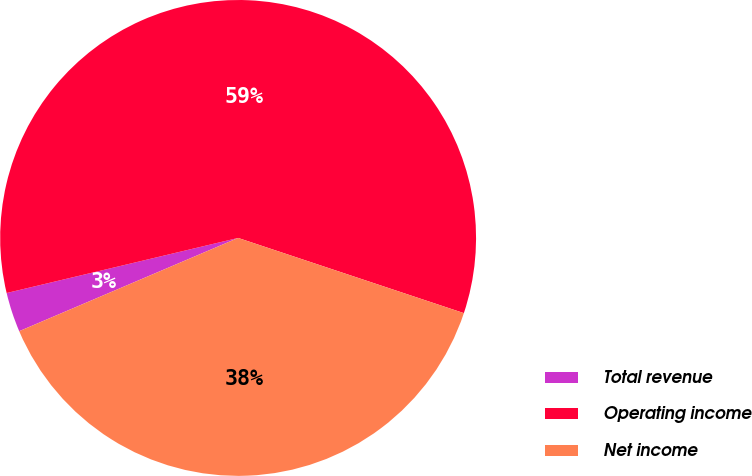<chart> <loc_0><loc_0><loc_500><loc_500><pie_chart><fcel>Total revenue<fcel>Operating income<fcel>Net income<nl><fcel>2.69%<fcel>58.83%<fcel>38.47%<nl></chart> 